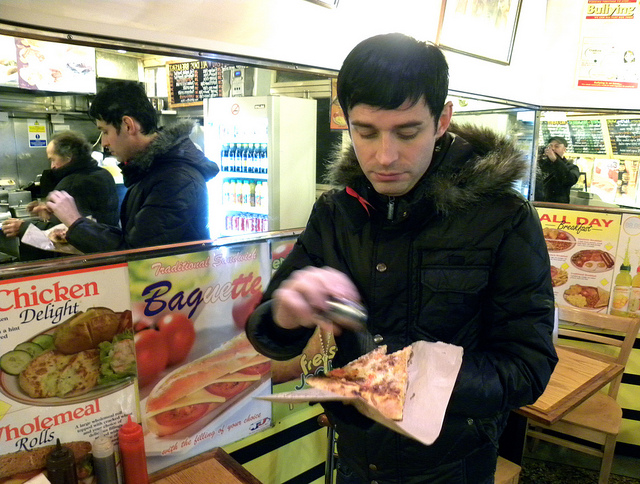What kind of establishment is the man in? The man is in a casual dining establishment that offers a variety of fast food options, such as pizza and sandwiches, as indicated by the signs. Does the place seem busy at the moment? Observing the image, there appear to be multiple customers around the man, suggesting a moderate level of activity within the establishment. 